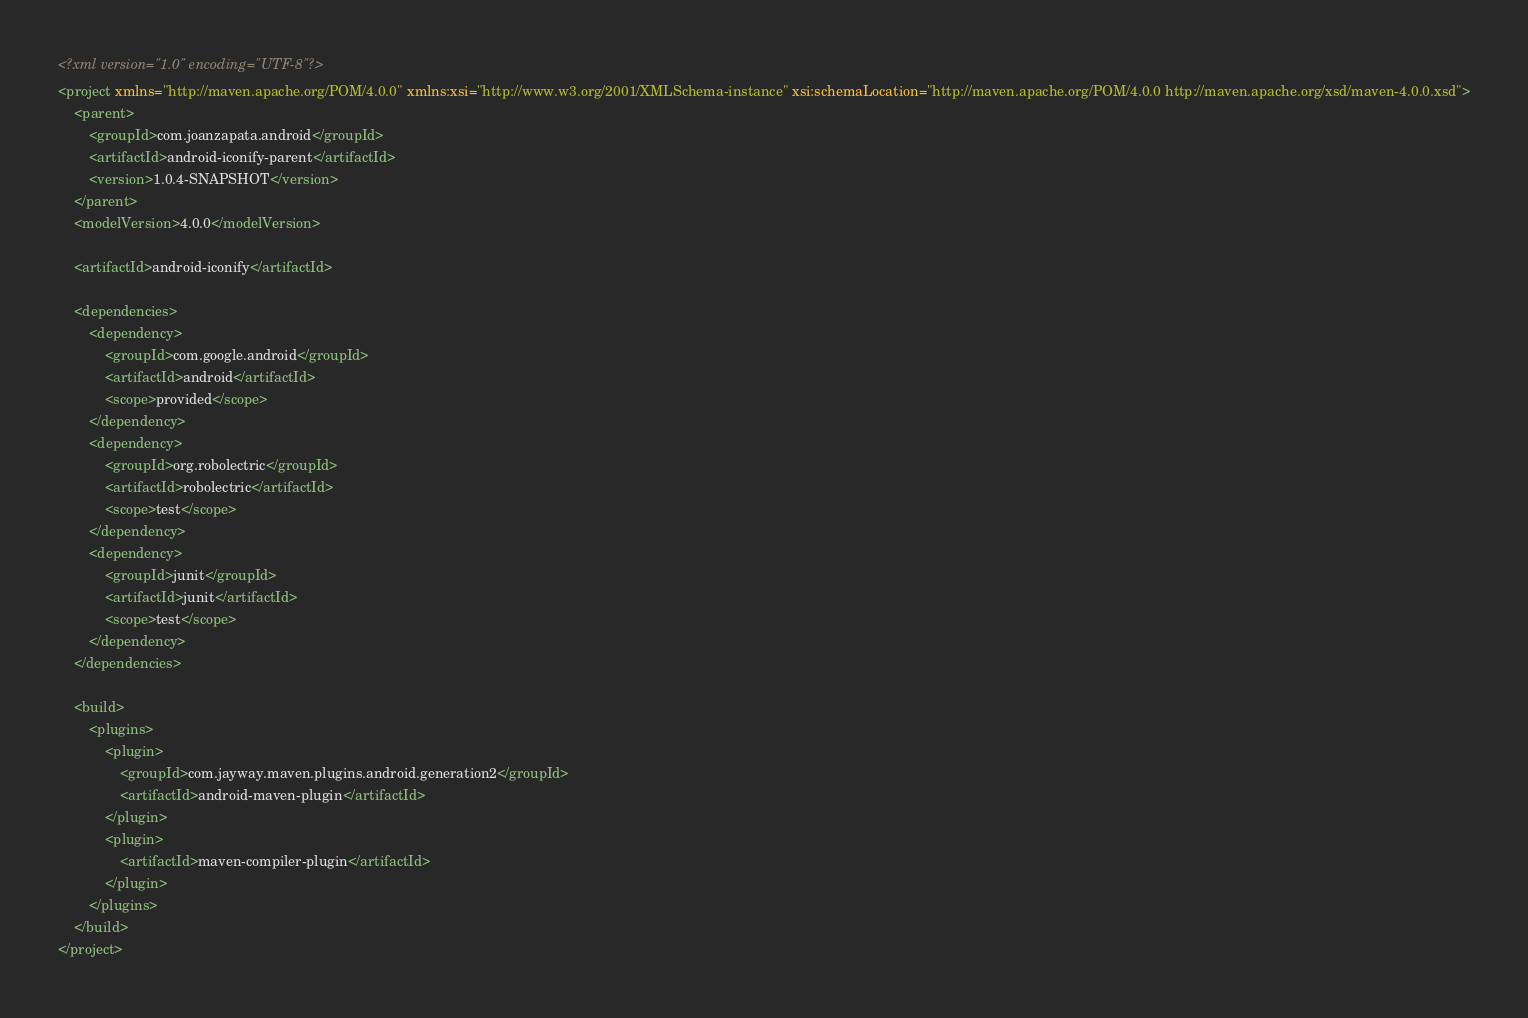Convert code to text. <code><loc_0><loc_0><loc_500><loc_500><_XML_><?xml version="1.0" encoding="UTF-8"?>
<project xmlns="http://maven.apache.org/POM/4.0.0" xmlns:xsi="http://www.w3.org/2001/XMLSchema-instance" xsi:schemaLocation="http://maven.apache.org/POM/4.0.0 http://maven.apache.org/xsd/maven-4.0.0.xsd">
    <parent>
        <groupId>com.joanzapata.android</groupId>
        <artifactId>android-iconify-parent</artifactId>
        <version>1.0.4-SNAPSHOT</version>
    </parent>
    <modelVersion>4.0.0</modelVersion>

    <artifactId>android-iconify</artifactId>

    <dependencies>
        <dependency>
            <groupId>com.google.android</groupId>
            <artifactId>android</artifactId>
            <scope>provided</scope>
        </dependency>
        <dependency>
            <groupId>org.robolectric</groupId>
            <artifactId>robolectric</artifactId>
            <scope>test</scope>
        </dependency>
        <dependency>
            <groupId>junit</groupId>
            <artifactId>junit</artifactId>
            <scope>test</scope>
        </dependency>
    </dependencies>

    <build>
        <plugins>
            <plugin>
                <groupId>com.jayway.maven.plugins.android.generation2</groupId>
                <artifactId>android-maven-plugin</artifactId>
            </plugin>
            <plugin>
                <artifactId>maven-compiler-plugin</artifactId>
            </plugin>
        </plugins>
    </build>
</project></code> 